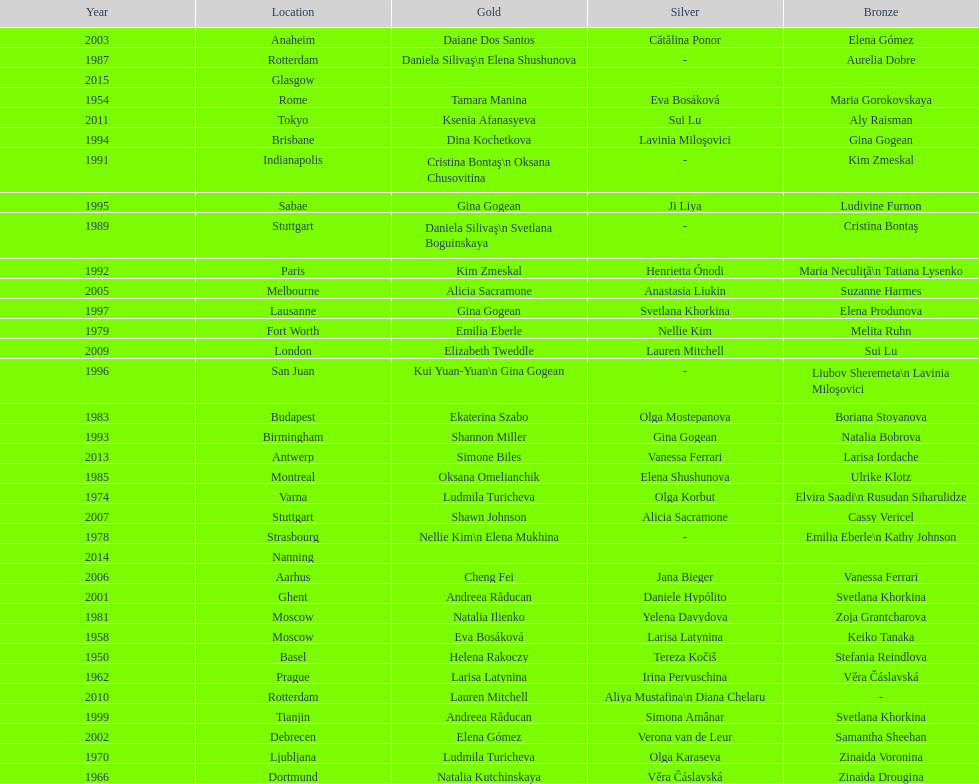As of 2013, what is the total number of floor exercise gold medals won by american women at the world championships? 5. 